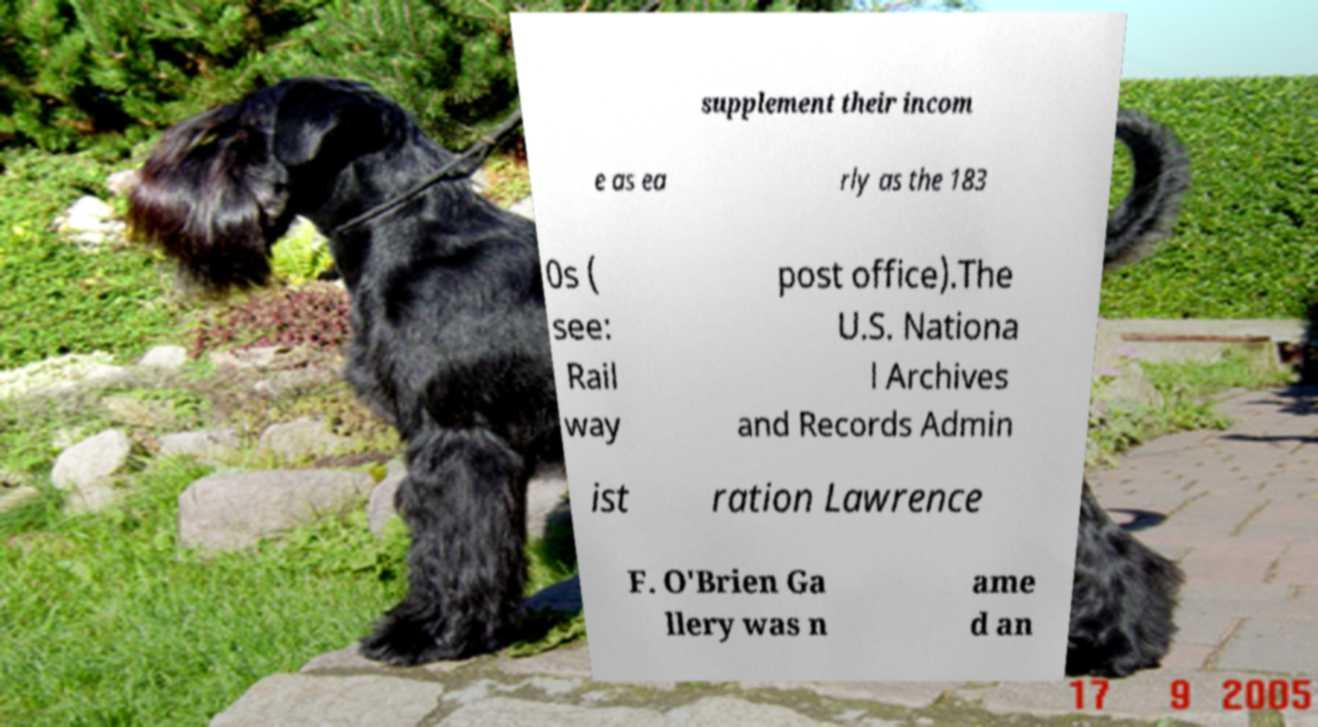I need the written content from this picture converted into text. Can you do that? supplement their incom e as ea rly as the 183 0s ( see: Rail way post office).The U.S. Nationa l Archives and Records Admin ist ration Lawrence F. O'Brien Ga llery was n ame d an 